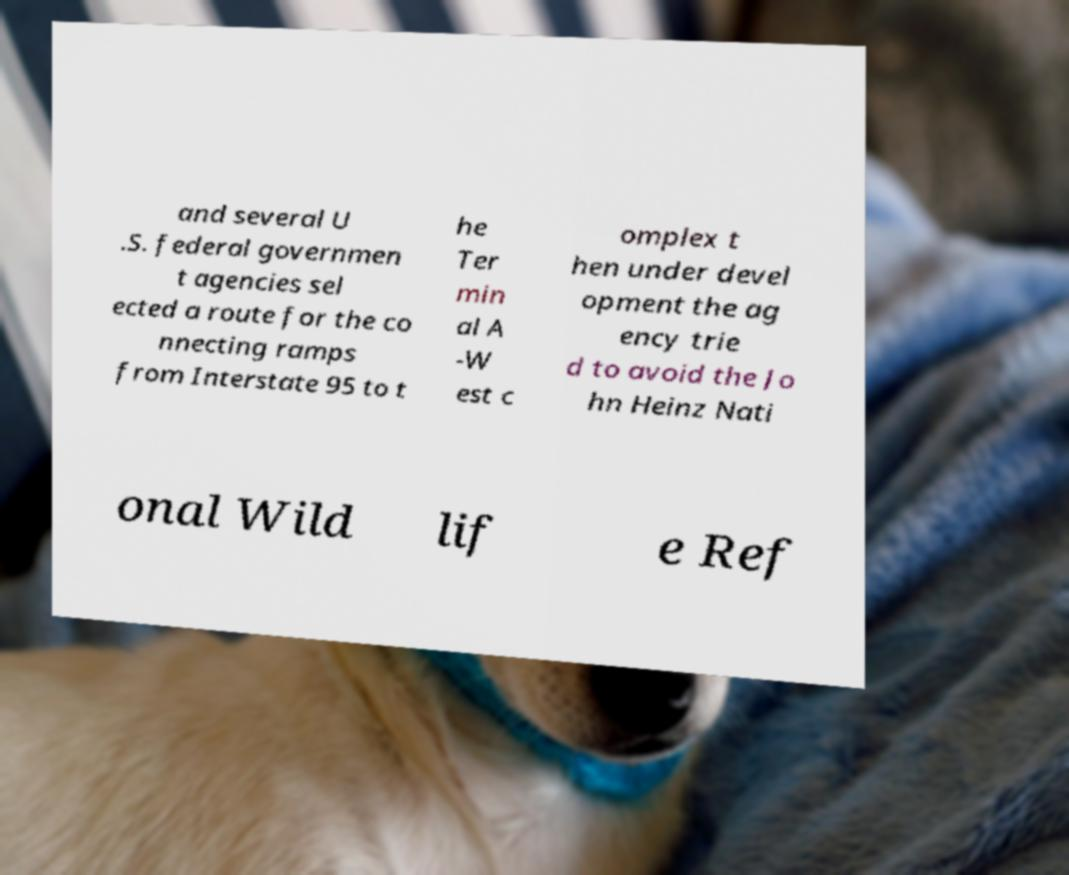Could you extract and type out the text from this image? and several U .S. federal governmen t agencies sel ected a route for the co nnecting ramps from Interstate 95 to t he Ter min al A -W est c omplex t hen under devel opment the ag ency trie d to avoid the Jo hn Heinz Nati onal Wild lif e Ref 